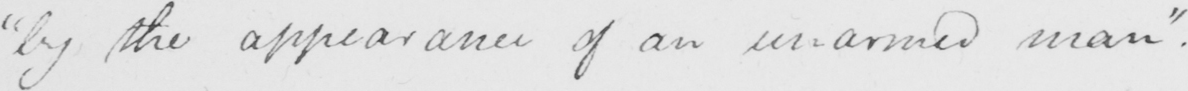Please provide the text content of this handwritten line. by the appearance of an unarmed man "  . 